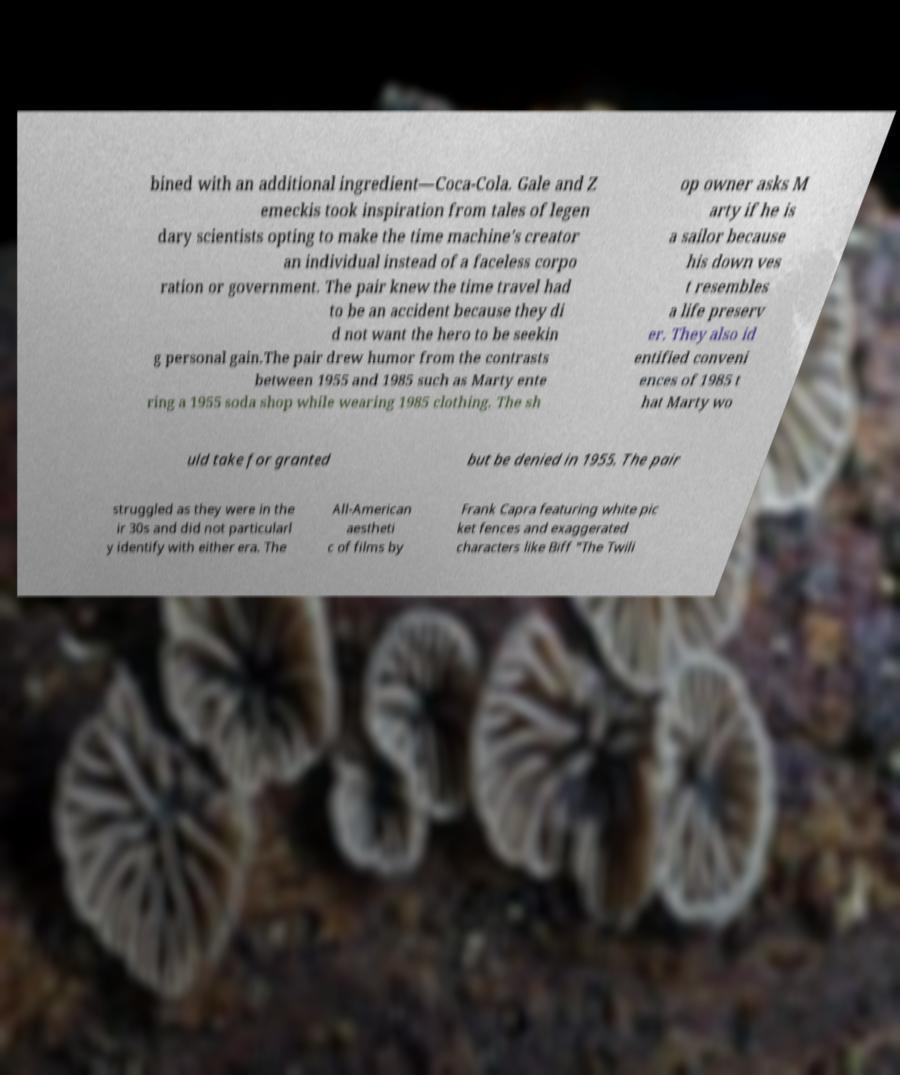Please read and relay the text visible in this image. What does it say? bined with an additional ingredient—Coca-Cola. Gale and Z emeckis took inspiration from tales of legen dary scientists opting to make the time machine's creator an individual instead of a faceless corpo ration or government. The pair knew the time travel had to be an accident because they di d not want the hero to be seekin g personal gain.The pair drew humor from the contrasts between 1955 and 1985 such as Marty ente ring a 1955 soda shop while wearing 1985 clothing. The sh op owner asks M arty if he is a sailor because his down ves t resembles a life preserv er. They also id entified conveni ences of 1985 t hat Marty wo uld take for granted but be denied in 1955. The pair struggled as they were in the ir 30s and did not particularl y identify with either era. The All-American aestheti c of films by Frank Capra featuring white pic ket fences and exaggerated characters like Biff "The Twili 